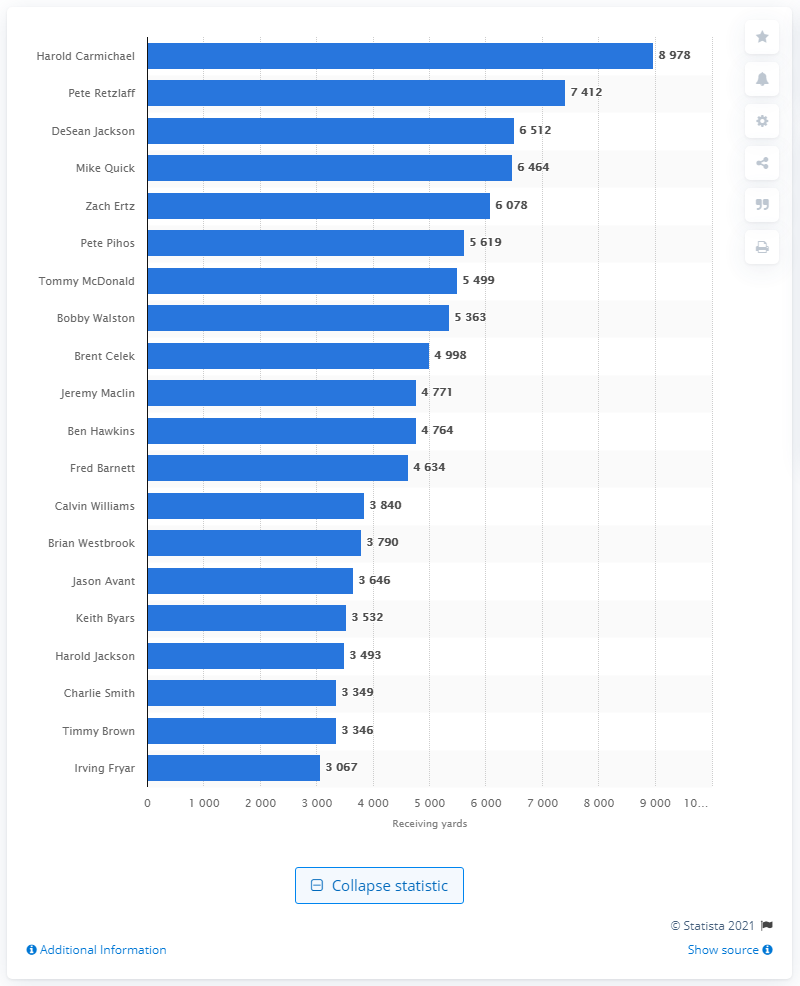Draw attention to some important aspects in this diagram. The career receiving leader of the Philadelphia Eagles is Harold Carmichael. 